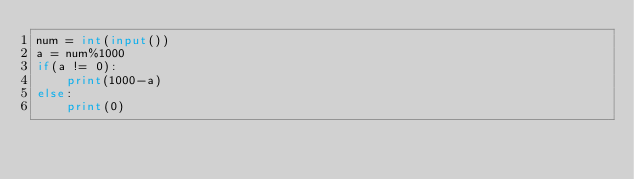<code> <loc_0><loc_0><loc_500><loc_500><_Python_>num = int(input())
a = num%1000
if(a != 0):
    print(1000-a)
else:
    print(0)</code> 